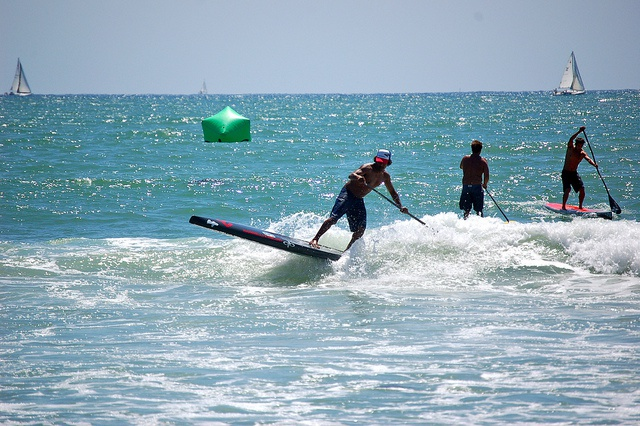Describe the objects in this image and their specific colors. I can see people in darkgray, black, navy, maroon, and teal tones, surfboard in darkgray, black, and gray tones, people in darkgray, black, gray, maroon, and teal tones, people in darkgray, black, teal, and gray tones, and boat in darkgray, lightgray, and gray tones in this image. 